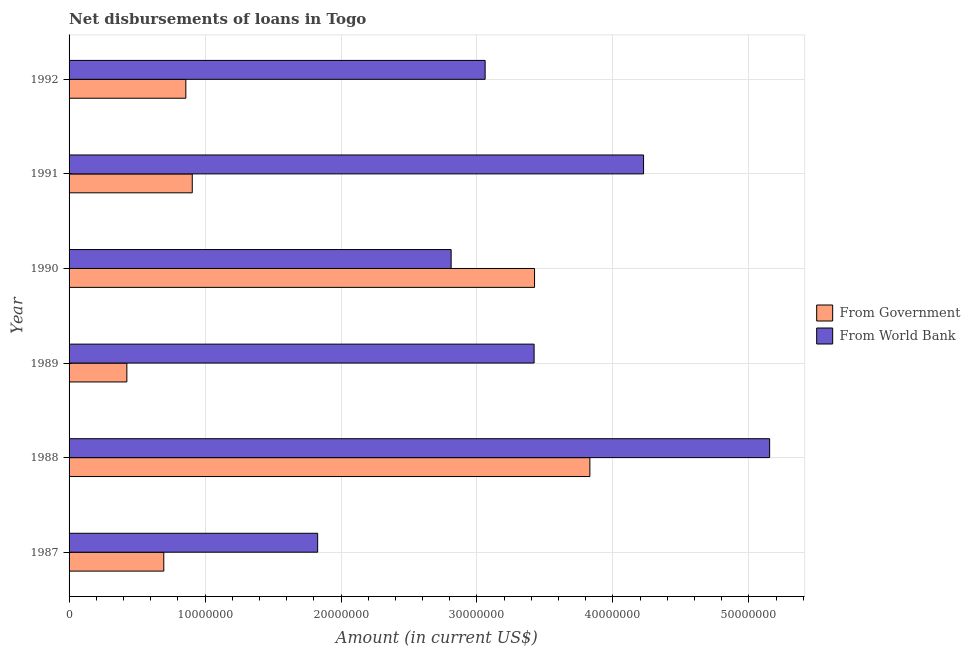Are the number of bars per tick equal to the number of legend labels?
Offer a very short reply. Yes. Are the number of bars on each tick of the Y-axis equal?
Offer a very short reply. Yes. What is the label of the 2nd group of bars from the top?
Ensure brevity in your answer.  1991. In how many cases, is the number of bars for a given year not equal to the number of legend labels?
Your answer should be compact. 0. What is the net disbursements of loan from government in 1992?
Give a very brief answer. 8.59e+06. Across all years, what is the maximum net disbursements of loan from government?
Give a very brief answer. 3.83e+07. Across all years, what is the minimum net disbursements of loan from world bank?
Ensure brevity in your answer.  1.83e+07. In which year was the net disbursements of loan from world bank maximum?
Your answer should be very brief. 1988. What is the total net disbursements of loan from world bank in the graph?
Offer a terse response. 2.05e+08. What is the difference between the net disbursements of loan from world bank in 1991 and that in 1992?
Give a very brief answer. 1.17e+07. What is the difference between the net disbursements of loan from world bank in 1992 and the net disbursements of loan from government in 1988?
Your answer should be very brief. -7.70e+06. What is the average net disbursements of loan from government per year?
Keep it short and to the point. 1.69e+07. In the year 1987, what is the difference between the net disbursements of loan from world bank and net disbursements of loan from government?
Your answer should be very brief. 1.13e+07. In how many years, is the net disbursements of loan from government greater than 10000000 US$?
Give a very brief answer. 2. What is the ratio of the net disbursements of loan from government in 1987 to that in 1991?
Provide a succinct answer. 0.77. What is the difference between the highest and the second highest net disbursements of loan from government?
Give a very brief answer. 4.07e+06. What is the difference between the highest and the lowest net disbursements of loan from government?
Keep it short and to the point. 3.41e+07. What does the 1st bar from the top in 1992 represents?
Provide a short and direct response. From World Bank. What does the 1st bar from the bottom in 1990 represents?
Ensure brevity in your answer.  From Government. How many years are there in the graph?
Offer a terse response. 6. What is the difference between two consecutive major ticks on the X-axis?
Offer a very short reply. 1.00e+07. Are the values on the major ticks of X-axis written in scientific E-notation?
Make the answer very short. No. Does the graph contain any zero values?
Give a very brief answer. No. Does the graph contain grids?
Provide a succinct answer. Yes. Where does the legend appear in the graph?
Your answer should be compact. Center right. How are the legend labels stacked?
Offer a terse response. Vertical. What is the title of the graph?
Provide a short and direct response. Net disbursements of loans in Togo. Does "Merchandise exports" appear as one of the legend labels in the graph?
Offer a very short reply. No. What is the label or title of the X-axis?
Give a very brief answer. Amount (in current US$). What is the Amount (in current US$) in From Government in 1987?
Provide a short and direct response. 6.97e+06. What is the Amount (in current US$) of From World Bank in 1987?
Give a very brief answer. 1.83e+07. What is the Amount (in current US$) in From Government in 1988?
Your answer should be compact. 3.83e+07. What is the Amount (in current US$) in From World Bank in 1988?
Your answer should be very brief. 5.15e+07. What is the Amount (in current US$) of From Government in 1989?
Provide a succinct answer. 4.25e+06. What is the Amount (in current US$) of From World Bank in 1989?
Your answer should be very brief. 3.42e+07. What is the Amount (in current US$) in From Government in 1990?
Provide a succinct answer. 3.42e+07. What is the Amount (in current US$) in From World Bank in 1990?
Give a very brief answer. 2.81e+07. What is the Amount (in current US$) in From Government in 1991?
Your response must be concise. 9.06e+06. What is the Amount (in current US$) of From World Bank in 1991?
Give a very brief answer. 4.23e+07. What is the Amount (in current US$) of From Government in 1992?
Give a very brief answer. 8.59e+06. What is the Amount (in current US$) of From World Bank in 1992?
Give a very brief answer. 3.06e+07. Across all years, what is the maximum Amount (in current US$) of From Government?
Ensure brevity in your answer.  3.83e+07. Across all years, what is the maximum Amount (in current US$) of From World Bank?
Offer a terse response. 5.15e+07. Across all years, what is the minimum Amount (in current US$) in From Government?
Offer a terse response. 4.25e+06. Across all years, what is the minimum Amount (in current US$) of From World Bank?
Provide a short and direct response. 1.83e+07. What is the total Amount (in current US$) of From Government in the graph?
Offer a terse response. 1.01e+08. What is the total Amount (in current US$) of From World Bank in the graph?
Offer a very short reply. 2.05e+08. What is the difference between the Amount (in current US$) of From Government in 1987 and that in 1988?
Your answer should be very brief. -3.13e+07. What is the difference between the Amount (in current US$) in From World Bank in 1987 and that in 1988?
Make the answer very short. -3.32e+07. What is the difference between the Amount (in current US$) of From Government in 1987 and that in 1989?
Keep it short and to the point. 2.72e+06. What is the difference between the Amount (in current US$) of From World Bank in 1987 and that in 1989?
Give a very brief answer. -1.59e+07. What is the difference between the Amount (in current US$) of From Government in 1987 and that in 1990?
Give a very brief answer. -2.73e+07. What is the difference between the Amount (in current US$) in From World Bank in 1987 and that in 1990?
Keep it short and to the point. -9.82e+06. What is the difference between the Amount (in current US$) in From Government in 1987 and that in 1991?
Give a very brief answer. -2.09e+06. What is the difference between the Amount (in current US$) of From World Bank in 1987 and that in 1991?
Provide a succinct answer. -2.40e+07. What is the difference between the Amount (in current US$) of From Government in 1987 and that in 1992?
Provide a succinct answer. -1.62e+06. What is the difference between the Amount (in current US$) in From World Bank in 1987 and that in 1992?
Ensure brevity in your answer.  -1.23e+07. What is the difference between the Amount (in current US$) in From Government in 1988 and that in 1989?
Your answer should be very brief. 3.41e+07. What is the difference between the Amount (in current US$) in From World Bank in 1988 and that in 1989?
Provide a short and direct response. 1.73e+07. What is the difference between the Amount (in current US$) of From Government in 1988 and that in 1990?
Offer a terse response. 4.07e+06. What is the difference between the Amount (in current US$) of From World Bank in 1988 and that in 1990?
Offer a terse response. 2.34e+07. What is the difference between the Amount (in current US$) in From Government in 1988 and that in 1991?
Offer a terse response. 2.92e+07. What is the difference between the Amount (in current US$) in From World Bank in 1988 and that in 1991?
Your response must be concise. 9.27e+06. What is the difference between the Amount (in current US$) in From Government in 1988 and that in 1992?
Make the answer very short. 2.97e+07. What is the difference between the Amount (in current US$) of From World Bank in 1988 and that in 1992?
Your answer should be compact. 2.09e+07. What is the difference between the Amount (in current US$) of From Government in 1989 and that in 1990?
Your answer should be compact. -3.00e+07. What is the difference between the Amount (in current US$) in From World Bank in 1989 and that in 1990?
Ensure brevity in your answer.  6.10e+06. What is the difference between the Amount (in current US$) of From Government in 1989 and that in 1991?
Your response must be concise. -4.81e+06. What is the difference between the Amount (in current US$) of From World Bank in 1989 and that in 1991?
Your answer should be very brief. -8.05e+06. What is the difference between the Amount (in current US$) in From Government in 1989 and that in 1992?
Your response must be concise. -4.34e+06. What is the difference between the Amount (in current US$) in From World Bank in 1989 and that in 1992?
Keep it short and to the point. 3.60e+06. What is the difference between the Amount (in current US$) of From Government in 1990 and that in 1991?
Give a very brief answer. 2.52e+07. What is the difference between the Amount (in current US$) in From World Bank in 1990 and that in 1991?
Give a very brief answer. -1.42e+07. What is the difference between the Amount (in current US$) in From Government in 1990 and that in 1992?
Make the answer very short. 2.56e+07. What is the difference between the Amount (in current US$) in From World Bank in 1990 and that in 1992?
Keep it short and to the point. -2.50e+06. What is the difference between the Amount (in current US$) of From Government in 1991 and that in 1992?
Make the answer very short. 4.72e+05. What is the difference between the Amount (in current US$) in From World Bank in 1991 and that in 1992?
Your response must be concise. 1.17e+07. What is the difference between the Amount (in current US$) of From Government in 1987 and the Amount (in current US$) of From World Bank in 1988?
Your response must be concise. -4.46e+07. What is the difference between the Amount (in current US$) in From Government in 1987 and the Amount (in current US$) in From World Bank in 1989?
Provide a short and direct response. -2.72e+07. What is the difference between the Amount (in current US$) in From Government in 1987 and the Amount (in current US$) in From World Bank in 1990?
Your answer should be compact. -2.11e+07. What is the difference between the Amount (in current US$) in From Government in 1987 and the Amount (in current US$) in From World Bank in 1991?
Your response must be concise. -3.53e+07. What is the difference between the Amount (in current US$) of From Government in 1987 and the Amount (in current US$) of From World Bank in 1992?
Ensure brevity in your answer.  -2.36e+07. What is the difference between the Amount (in current US$) of From Government in 1988 and the Amount (in current US$) of From World Bank in 1989?
Your response must be concise. 4.10e+06. What is the difference between the Amount (in current US$) of From Government in 1988 and the Amount (in current US$) of From World Bank in 1990?
Your answer should be very brief. 1.02e+07. What is the difference between the Amount (in current US$) in From Government in 1988 and the Amount (in current US$) in From World Bank in 1991?
Offer a terse response. -3.95e+06. What is the difference between the Amount (in current US$) in From Government in 1988 and the Amount (in current US$) in From World Bank in 1992?
Provide a succinct answer. 7.70e+06. What is the difference between the Amount (in current US$) of From Government in 1989 and the Amount (in current US$) of From World Bank in 1990?
Your response must be concise. -2.38e+07. What is the difference between the Amount (in current US$) of From Government in 1989 and the Amount (in current US$) of From World Bank in 1991?
Your answer should be compact. -3.80e+07. What is the difference between the Amount (in current US$) of From Government in 1989 and the Amount (in current US$) of From World Bank in 1992?
Ensure brevity in your answer.  -2.64e+07. What is the difference between the Amount (in current US$) of From Government in 1990 and the Amount (in current US$) of From World Bank in 1991?
Keep it short and to the point. -8.02e+06. What is the difference between the Amount (in current US$) of From Government in 1990 and the Amount (in current US$) of From World Bank in 1992?
Give a very brief answer. 3.63e+06. What is the difference between the Amount (in current US$) in From Government in 1991 and the Amount (in current US$) in From World Bank in 1992?
Ensure brevity in your answer.  -2.15e+07. What is the average Amount (in current US$) of From Government per year?
Your answer should be very brief. 1.69e+07. What is the average Amount (in current US$) in From World Bank per year?
Provide a short and direct response. 3.42e+07. In the year 1987, what is the difference between the Amount (in current US$) in From Government and Amount (in current US$) in From World Bank?
Your response must be concise. -1.13e+07. In the year 1988, what is the difference between the Amount (in current US$) of From Government and Amount (in current US$) of From World Bank?
Provide a short and direct response. -1.32e+07. In the year 1989, what is the difference between the Amount (in current US$) in From Government and Amount (in current US$) in From World Bank?
Provide a succinct answer. -3.00e+07. In the year 1990, what is the difference between the Amount (in current US$) of From Government and Amount (in current US$) of From World Bank?
Offer a very short reply. 6.13e+06. In the year 1991, what is the difference between the Amount (in current US$) of From Government and Amount (in current US$) of From World Bank?
Give a very brief answer. -3.32e+07. In the year 1992, what is the difference between the Amount (in current US$) of From Government and Amount (in current US$) of From World Bank?
Offer a terse response. -2.20e+07. What is the ratio of the Amount (in current US$) in From Government in 1987 to that in 1988?
Offer a terse response. 0.18. What is the ratio of the Amount (in current US$) in From World Bank in 1987 to that in 1988?
Provide a succinct answer. 0.35. What is the ratio of the Amount (in current US$) in From Government in 1987 to that in 1989?
Your answer should be compact. 1.64. What is the ratio of the Amount (in current US$) in From World Bank in 1987 to that in 1989?
Your answer should be compact. 0.53. What is the ratio of the Amount (in current US$) of From Government in 1987 to that in 1990?
Offer a terse response. 0.2. What is the ratio of the Amount (in current US$) in From World Bank in 1987 to that in 1990?
Keep it short and to the point. 0.65. What is the ratio of the Amount (in current US$) in From Government in 1987 to that in 1991?
Ensure brevity in your answer.  0.77. What is the ratio of the Amount (in current US$) of From World Bank in 1987 to that in 1991?
Give a very brief answer. 0.43. What is the ratio of the Amount (in current US$) of From Government in 1987 to that in 1992?
Your response must be concise. 0.81. What is the ratio of the Amount (in current US$) of From World Bank in 1987 to that in 1992?
Offer a terse response. 0.6. What is the ratio of the Amount (in current US$) of From Government in 1988 to that in 1989?
Make the answer very short. 9.01. What is the ratio of the Amount (in current US$) in From World Bank in 1988 to that in 1989?
Your answer should be compact. 1.51. What is the ratio of the Amount (in current US$) of From Government in 1988 to that in 1990?
Offer a terse response. 1.12. What is the ratio of the Amount (in current US$) in From World Bank in 1988 to that in 1990?
Offer a terse response. 1.83. What is the ratio of the Amount (in current US$) in From Government in 1988 to that in 1991?
Give a very brief answer. 4.23. What is the ratio of the Amount (in current US$) of From World Bank in 1988 to that in 1991?
Make the answer very short. 1.22. What is the ratio of the Amount (in current US$) in From Government in 1988 to that in 1992?
Provide a short and direct response. 4.46. What is the ratio of the Amount (in current US$) in From World Bank in 1988 to that in 1992?
Provide a succinct answer. 1.68. What is the ratio of the Amount (in current US$) of From Government in 1989 to that in 1990?
Provide a succinct answer. 0.12. What is the ratio of the Amount (in current US$) of From World Bank in 1989 to that in 1990?
Give a very brief answer. 1.22. What is the ratio of the Amount (in current US$) of From Government in 1989 to that in 1991?
Provide a short and direct response. 0.47. What is the ratio of the Amount (in current US$) in From World Bank in 1989 to that in 1991?
Offer a terse response. 0.81. What is the ratio of the Amount (in current US$) in From Government in 1989 to that in 1992?
Ensure brevity in your answer.  0.49. What is the ratio of the Amount (in current US$) in From World Bank in 1989 to that in 1992?
Offer a terse response. 1.12. What is the ratio of the Amount (in current US$) in From Government in 1990 to that in 1991?
Provide a short and direct response. 3.78. What is the ratio of the Amount (in current US$) of From World Bank in 1990 to that in 1991?
Provide a short and direct response. 0.67. What is the ratio of the Amount (in current US$) of From Government in 1990 to that in 1992?
Your answer should be very brief. 3.99. What is the ratio of the Amount (in current US$) of From World Bank in 1990 to that in 1992?
Offer a terse response. 0.92. What is the ratio of the Amount (in current US$) of From Government in 1991 to that in 1992?
Provide a short and direct response. 1.05. What is the ratio of the Amount (in current US$) in From World Bank in 1991 to that in 1992?
Your answer should be very brief. 1.38. What is the difference between the highest and the second highest Amount (in current US$) of From Government?
Provide a short and direct response. 4.07e+06. What is the difference between the highest and the second highest Amount (in current US$) in From World Bank?
Ensure brevity in your answer.  9.27e+06. What is the difference between the highest and the lowest Amount (in current US$) of From Government?
Keep it short and to the point. 3.41e+07. What is the difference between the highest and the lowest Amount (in current US$) of From World Bank?
Offer a very short reply. 3.32e+07. 